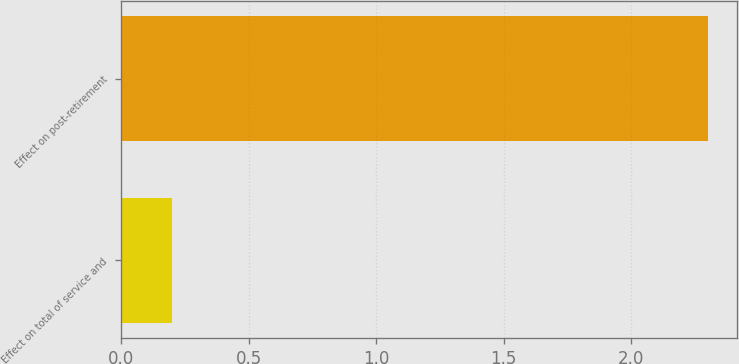Convert chart. <chart><loc_0><loc_0><loc_500><loc_500><bar_chart><fcel>Effect on total of service and<fcel>Effect on post-retirement<nl><fcel>0.2<fcel>2.3<nl></chart> 